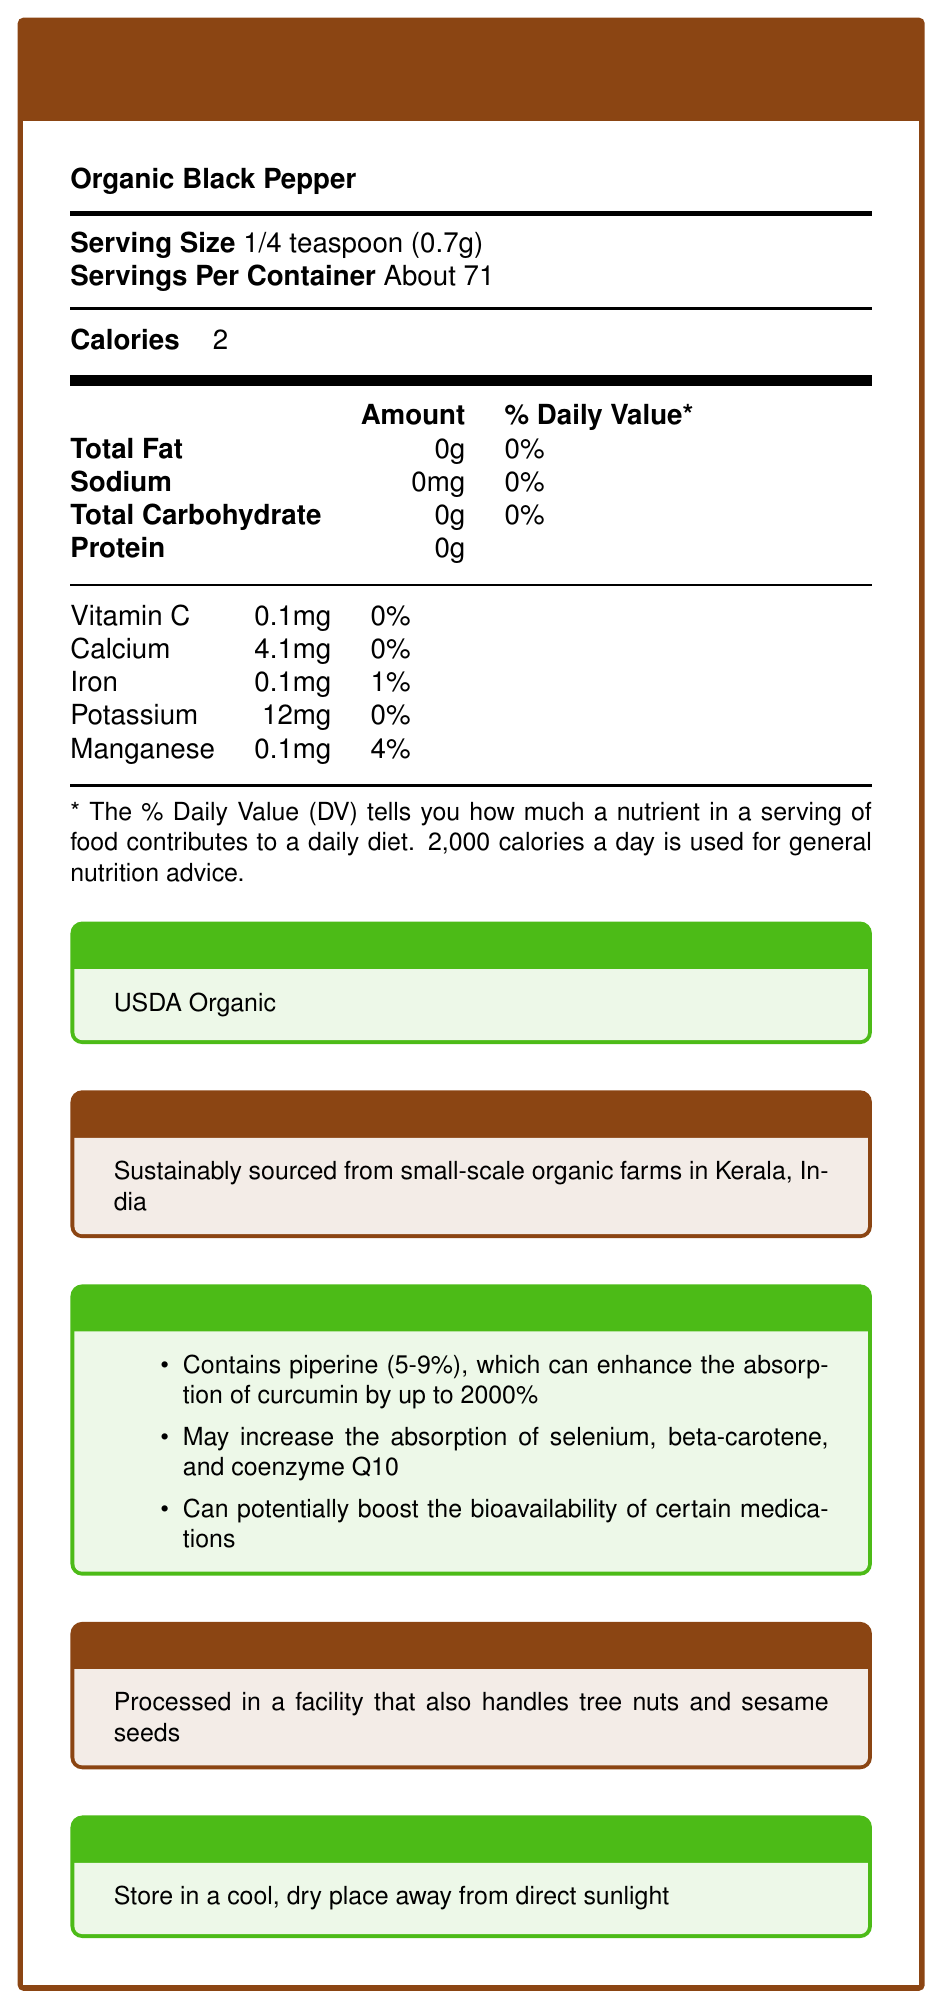what is the serving size? The serving size is clearly stated in the document as 1/4 teaspoon (0.7g).
Answer: 1/4 teaspoon (0.7g) how many calories are in one serving? The document states that there are 2 calories in one serving.
Answer: 2 calories how much iron is in each serving? The document specifies that each serving contains 0.1mg of iron.
Answer: 0.1mg what is the daily value percentage for manganese? The daily value percentage for manganese is listed as 4%.
Answer: 4% where is the organic black pepper sourced from? The sourcing information box indicates that the black pepper is sustainably sourced from small-scale organic farms in Kerala, India.
Answer: Kerala, India which organization certifies the organic status of the black pepper? A. USDA B. FDA C. WHO The document lists "USDA Organic" as the certifying body for its organic status.
Answer: A which nutrient is not significantly contributed by this black pepper? A. Sodium B. Vitamin C C. Calcium D. All of the above Sodium, vitamin C, and calcium are all at very low amounts, contributing 0% to the daily value.
Answer: D does the document mention any allergen information? The document mentions that the product is processed in a facility that also handles tree nuts and sesame seeds.
Answer: Yes does the black pepper contribute to the daily intake of beta-carotene? The document does not provide any information about the beta-carotene content in the black pepper.
Answer: Cannot be determined summarize the main benefits of this organic black pepper. The document highlights multiple benefits, including nutrient absorption enhancement due to piperine content, a commitment to sustainable farming, being 100% organic, rich in antioxidants, and free of artificial additives.
Answer: Enhances nutrient absorption, supports sustainable farming, is 100% organic, rich in antioxidants, and contains no artificial additives or preservatives. how does piperine in organic black pepper enhance curcumin absorption? The document states that piperine can enhance the absorption of curcumin by up to 2000%, as noted in the "Nutrient Absorption Benefits" section.
Answer: By up to 2000% what storage instructions are provided for the organic black pepper? The document provides specific storage instructions to maintain product quality.
Answer: Store in a cool, dry place away from direct sunlight how many servings are approximately in one container? The document mentions that there are "About 71" servings per container.
Answer: About 71 servings what is the percentage of piperine content in the organic black pepper? The document indicates that the piperine content ranges between 5-9%.
Answer: 5-9% what are the brand values associated with this product? These are listed in the "brand values" section of the document.
Answer: Commitment to organic agriculture, transparency in sourcing, supporting small-scale farmers, promoting health and wellness through natural ingredients does the black pepper contain any artificial additives or preservatives? The document explicitly mentions that the product has no artificial additives or preservatives.
Answer: No 